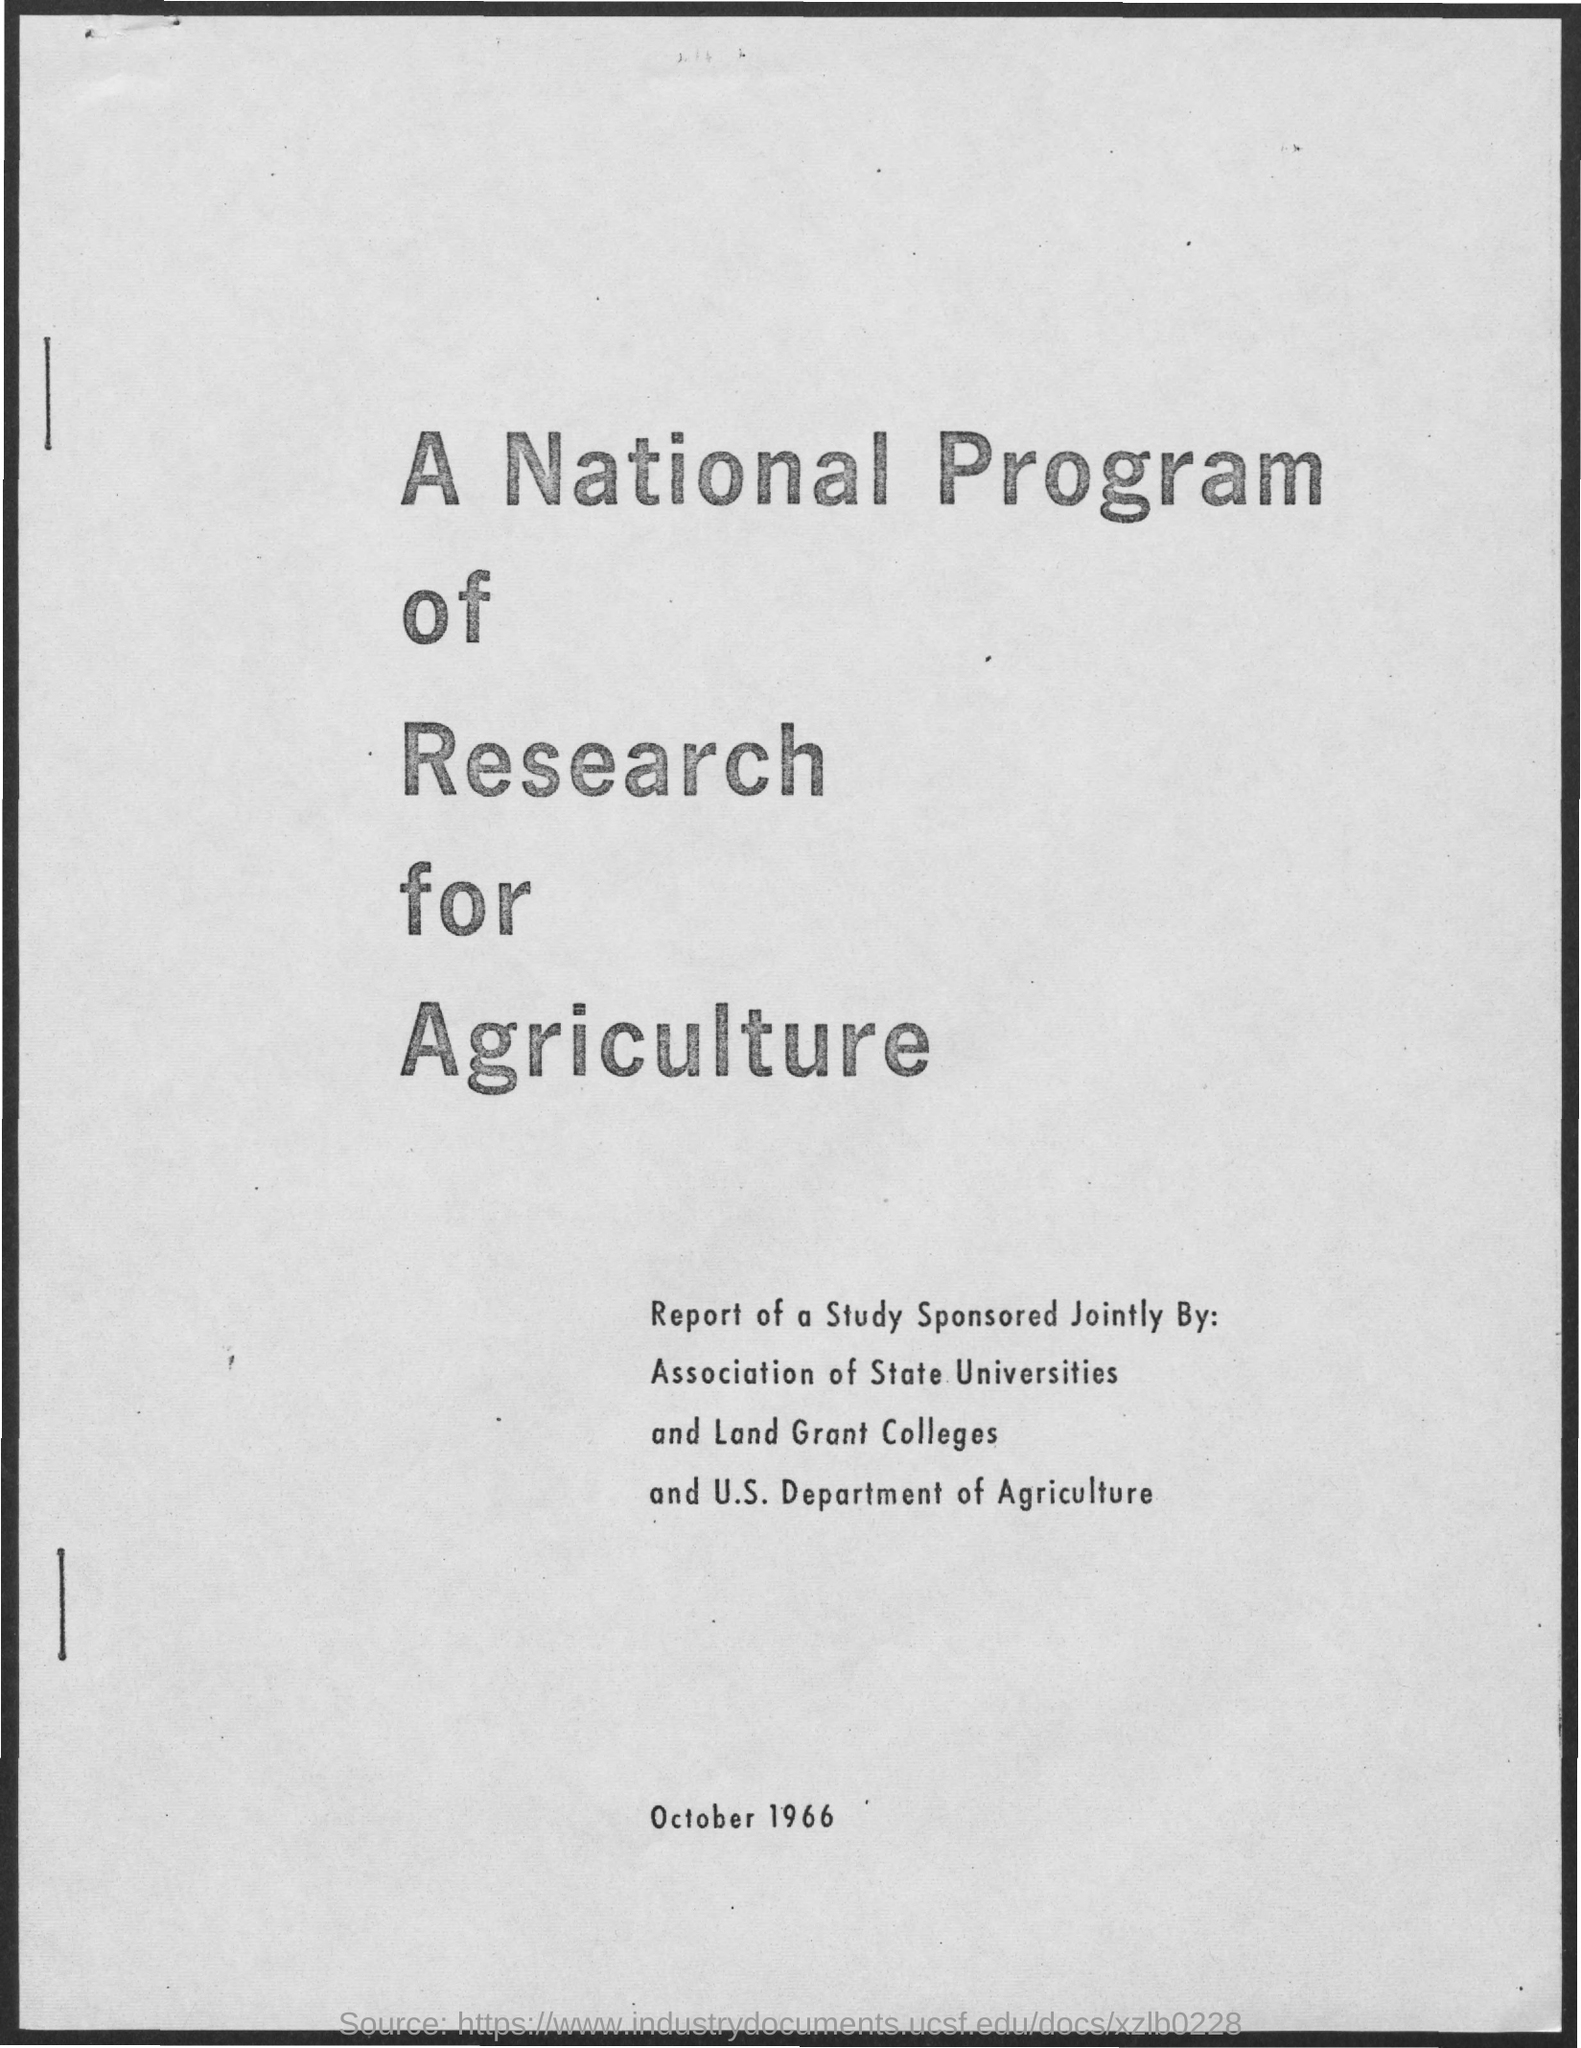Indicate a few pertinent items in this graphic. The date on the document is October 1966. 